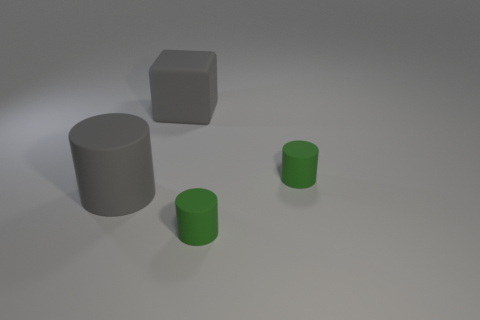Subtract all green cylinders. How many were subtracted if there are1green cylinders left? 1 Subtract all big matte cylinders. How many cylinders are left? 2 Subtract all cylinders. How many objects are left? 1 Subtract 1 cylinders. How many cylinders are left? 2 Subtract all gray cylinders. How many cylinders are left? 2 Subtract 1 gray cubes. How many objects are left? 3 Subtract all blue cylinders. Subtract all purple cubes. How many cylinders are left? 3 Subtract all cyan balls. How many yellow cylinders are left? 0 Subtract all large red blocks. Subtract all gray rubber cylinders. How many objects are left? 3 Add 4 large gray rubber cylinders. How many large gray rubber cylinders are left? 5 